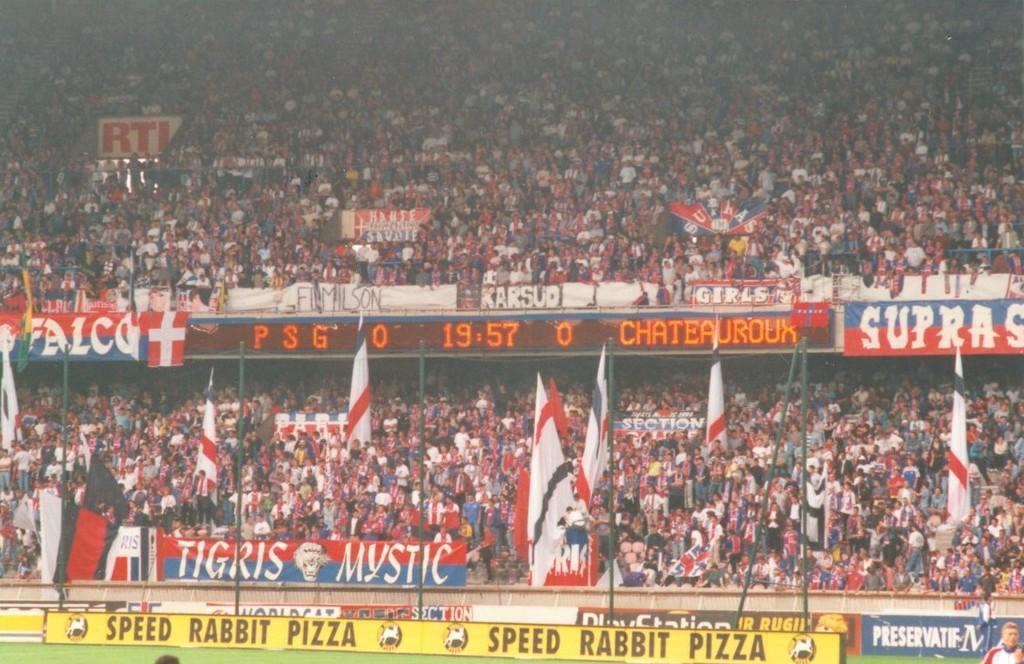Please provide a concise description of this image. In this image we can see there are people standing in the stadium. And there are boards with the text and there is a screen, banners, ground and flags. 